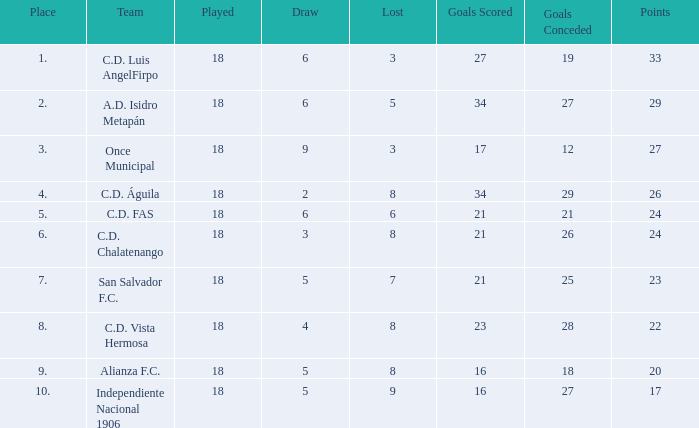What are the number of goals conceded that has a played greater than 18? 0.0. 